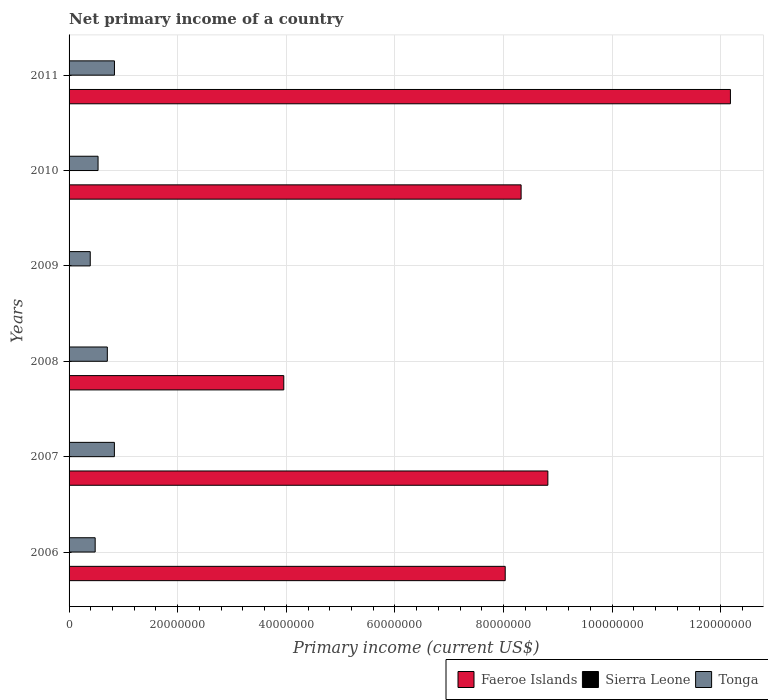Are the number of bars per tick equal to the number of legend labels?
Offer a terse response. No. Are the number of bars on each tick of the Y-axis equal?
Ensure brevity in your answer.  No. How many bars are there on the 3rd tick from the top?
Make the answer very short. 1. How many bars are there on the 6th tick from the bottom?
Your response must be concise. 2. What is the label of the 2nd group of bars from the top?
Make the answer very short. 2010. What is the primary income in Sierra Leone in 2007?
Offer a terse response. 0. Across all years, what is the maximum primary income in Tonga?
Your answer should be very brief. 8.36e+06. What is the total primary income in Sierra Leone in the graph?
Give a very brief answer. 0. What is the difference between the primary income in Faeroe Islands in 2008 and that in 2010?
Provide a short and direct response. -4.37e+07. What is the difference between the primary income in Sierra Leone in 2010 and the primary income in Faeroe Islands in 2007?
Make the answer very short. -8.82e+07. What is the average primary income in Faeroe Islands per year?
Your response must be concise. 6.88e+07. In the year 2010, what is the difference between the primary income in Tonga and primary income in Faeroe Islands?
Give a very brief answer. -7.79e+07. What is the ratio of the primary income in Faeroe Islands in 2008 to that in 2010?
Give a very brief answer. 0.47. Is the primary income in Faeroe Islands in 2010 less than that in 2011?
Ensure brevity in your answer.  Yes. Is the difference between the primary income in Tonga in 2006 and 2008 greater than the difference between the primary income in Faeroe Islands in 2006 and 2008?
Provide a succinct answer. No. What is the difference between the highest and the second highest primary income in Tonga?
Provide a short and direct response. 1.11e+04. What is the difference between the highest and the lowest primary income in Faeroe Islands?
Your answer should be very brief. 1.22e+08. Is the sum of the primary income in Tonga in 2006 and 2008 greater than the maximum primary income in Sierra Leone across all years?
Your answer should be compact. Yes. How many bars are there?
Provide a short and direct response. 11. Are all the bars in the graph horizontal?
Keep it short and to the point. Yes. Does the graph contain any zero values?
Your response must be concise. Yes. Does the graph contain grids?
Keep it short and to the point. Yes. How many legend labels are there?
Your answer should be very brief. 3. What is the title of the graph?
Your answer should be very brief. Net primary income of a country. Does "Europe(developing only)" appear as one of the legend labels in the graph?
Your response must be concise. No. What is the label or title of the X-axis?
Give a very brief answer. Primary income (current US$). What is the Primary income (current US$) in Faeroe Islands in 2006?
Ensure brevity in your answer.  8.03e+07. What is the Primary income (current US$) in Sierra Leone in 2006?
Your answer should be very brief. 0. What is the Primary income (current US$) of Tonga in 2006?
Ensure brevity in your answer.  4.81e+06. What is the Primary income (current US$) in Faeroe Islands in 2007?
Make the answer very short. 8.82e+07. What is the Primary income (current US$) in Tonga in 2007?
Your answer should be compact. 8.35e+06. What is the Primary income (current US$) in Faeroe Islands in 2008?
Your response must be concise. 3.95e+07. What is the Primary income (current US$) of Sierra Leone in 2008?
Ensure brevity in your answer.  0. What is the Primary income (current US$) of Tonga in 2008?
Keep it short and to the point. 7.04e+06. What is the Primary income (current US$) of Tonga in 2009?
Keep it short and to the point. 3.90e+06. What is the Primary income (current US$) in Faeroe Islands in 2010?
Keep it short and to the point. 8.32e+07. What is the Primary income (current US$) of Sierra Leone in 2010?
Make the answer very short. 0. What is the Primary income (current US$) of Tonga in 2010?
Your answer should be compact. 5.34e+06. What is the Primary income (current US$) in Faeroe Islands in 2011?
Offer a terse response. 1.22e+08. What is the Primary income (current US$) in Tonga in 2011?
Keep it short and to the point. 8.36e+06. Across all years, what is the maximum Primary income (current US$) of Faeroe Islands?
Offer a very short reply. 1.22e+08. Across all years, what is the maximum Primary income (current US$) of Tonga?
Offer a very short reply. 8.36e+06. Across all years, what is the minimum Primary income (current US$) of Faeroe Islands?
Ensure brevity in your answer.  0. Across all years, what is the minimum Primary income (current US$) of Tonga?
Provide a short and direct response. 3.90e+06. What is the total Primary income (current US$) in Faeroe Islands in the graph?
Make the answer very short. 4.13e+08. What is the total Primary income (current US$) in Sierra Leone in the graph?
Make the answer very short. 0. What is the total Primary income (current US$) in Tonga in the graph?
Keep it short and to the point. 3.78e+07. What is the difference between the Primary income (current US$) in Faeroe Islands in 2006 and that in 2007?
Give a very brief answer. -7.85e+06. What is the difference between the Primary income (current US$) in Tonga in 2006 and that in 2007?
Offer a very short reply. -3.54e+06. What is the difference between the Primary income (current US$) of Faeroe Islands in 2006 and that in 2008?
Offer a terse response. 4.08e+07. What is the difference between the Primary income (current US$) in Tonga in 2006 and that in 2008?
Provide a succinct answer. -2.24e+06. What is the difference between the Primary income (current US$) of Tonga in 2006 and that in 2009?
Your answer should be compact. 9.08e+05. What is the difference between the Primary income (current US$) of Faeroe Islands in 2006 and that in 2010?
Make the answer very short. -2.93e+06. What is the difference between the Primary income (current US$) in Tonga in 2006 and that in 2010?
Keep it short and to the point. -5.31e+05. What is the difference between the Primary income (current US$) in Faeroe Islands in 2006 and that in 2011?
Make the answer very short. -4.15e+07. What is the difference between the Primary income (current US$) in Tonga in 2006 and that in 2011?
Your answer should be very brief. -3.55e+06. What is the difference between the Primary income (current US$) of Faeroe Islands in 2007 and that in 2008?
Offer a terse response. 4.86e+07. What is the difference between the Primary income (current US$) in Tonga in 2007 and that in 2008?
Provide a short and direct response. 1.30e+06. What is the difference between the Primary income (current US$) of Tonga in 2007 and that in 2009?
Make the answer very short. 4.45e+06. What is the difference between the Primary income (current US$) of Faeroe Islands in 2007 and that in 2010?
Provide a short and direct response. 4.93e+06. What is the difference between the Primary income (current US$) in Tonga in 2007 and that in 2010?
Make the answer very short. 3.01e+06. What is the difference between the Primary income (current US$) in Faeroe Islands in 2007 and that in 2011?
Keep it short and to the point. -3.36e+07. What is the difference between the Primary income (current US$) in Tonga in 2007 and that in 2011?
Your response must be concise. -1.11e+04. What is the difference between the Primary income (current US$) in Tonga in 2008 and that in 2009?
Offer a terse response. 3.14e+06. What is the difference between the Primary income (current US$) of Faeroe Islands in 2008 and that in 2010?
Keep it short and to the point. -4.37e+07. What is the difference between the Primary income (current US$) of Tonga in 2008 and that in 2010?
Provide a succinct answer. 1.71e+06. What is the difference between the Primary income (current US$) of Faeroe Islands in 2008 and that in 2011?
Provide a succinct answer. -8.22e+07. What is the difference between the Primary income (current US$) in Tonga in 2008 and that in 2011?
Offer a very short reply. -1.31e+06. What is the difference between the Primary income (current US$) of Tonga in 2009 and that in 2010?
Provide a short and direct response. -1.44e+06. What is the difference between the Primary income (current US$) in Tonga in 2009 and that in 2011?
Make the answer very short. -4.46e+06. What is the difference between the Primary income (current US$) of Faeroe Islands in 2010 and that in 2011?
Make the answer very short. -3.85e+07. What is the difference between the Primary income (current US$) in Tonga in 2010 and that in 2011?
Make the answer very short. -3.02e+06. What is the difference between the Primary income (current US$) of Faeroe Islands in 2006 and the Primary income (current US$) of Tonga in 2007?
Keep it short and to the point. 7.20e+07. What is the difference between the Primary income (current US$) in Faeroe Islands in 2006 and the Primary income (current US$) in Tonga in 2008?
Make the answer very short. 7.33e+07. What is the difference between the Primary income (current US$) in Faeroe Islands in 2006 and the Primary income (current US$) in Tonga in 2009?
Your answer should be very brief. 7.64e+07. What is the difference between the Primary income (current US$) in Faeroe Islands in 2006 and the Primary income (current US$) in Tonga in 2010?
Give a very brief answer. 7.50e+07. What is the difference between the Primary income (current US$) of Faeroe Islands in 2006 and the Primary income (current US$) of Tonga in 2011?
Your answer should be very brief. 7.20e+07. What is the difference between the Primary income (current US$) in Faeroe Islands in 2007 and the Primary income (current US$) in Tonga in 2008?
Your answer should be very brief. 8.11e+07. What is the difference between the Primary income (current US$) in Faeroe Islands in 2007 and the Primary income (current US$) in Tonga in 2009?
Ensure brevity in your answer.  8.43e+07. What is the difference between the Primary income (current US$) in Faeroe Islands in 2007 and the Primary income (current US$) in Tonga in 2010?
Ensure brevity in your answer.  8.28e+07. What is the difference between the Primary income (current US$) in Faeroe Islands in 2007 and the Primary income (current US$) in Tonga in 2011?
Your response must be concise. 7.98e+07. What is the difference between the Primary income (current US$) in Faeroe Islands in 2008 and the Primary income (current US$) in Tonga in 2009?
Provide a short and direct response. 3.56e+07. What is the difference between the Primary income (current US$) of Faeroe Islands in 2008 and the Primary income (current US$) of Tonga in 2010?
Your answer should be compact. 3.42e+07. What is the difference between the Primary income (current US$) in Faeroe Islands in 2008 and the Primary income (current US$) in Tonga in 2011?
Give a very brief answer. 3.12e+07. What is the difference between the Primary income (current US$) in Faeroe Islands in 2010 and the Primary income (current US$) in Tonga in 2011?
Your answer should be compact. 7.49e+07. What is the average Primary income (current US$) in Faeroe Islands per year?
Offer a terse response. 6.88e+07. What is the average Primary income (current US$) in Tonga per year?
Your answer should be compact. 6.30e+06. In the year 2006, what is the difference between the Primary income (current US$) of Faeroe Islands and Primary income (current US$) of Tonga?
Offer a very short reply. 7.55e+07. In the year 2007, what is the difference between the Primary income (current US$) in Faeroe Islands and Primary income (current US$) in Tonga?
Ensure brevity in your answer.  7.98e+07. In the year 2008, what is the difference between the Primary income (current US$) in Faeroe Islands and Primary income (current US$) in Tonga?
Provide a short and direct response. 3.25e+07. In the year 2010, what is the difference between the Primary income (current US$) of Faeroe Islands and Primary income (current US$) of Tonga?
Offer a very short reply. 7.79e+07. In the year 2011, what is the difference between the Primary income (current US$) of Faeroe Islands and Primary income (current US$) of Tonga?
Offer a terse response. 1.13e+08. What is the ratio of the Primary income (current US$) of Faeroe Islands in 2006 to that in 2007?
Your answer should be compact. 0.91. What is the ratio of the Primary income (current US$) in Tonga in 2006 to that in 2007?
Make the answer very short. 0.58. What is the ratio of the Primary income (current US$) in Faeroe Islands in 2006 to that in 2008?
Offer a very short reply. 2.03. What is the ratio of the Primary income (current US$) in Tonga in 2006 to that in 2008?
Your response must be concise. 0.68. What is the ratio of the Primary income (current US$) of Tonga in 2006 to that in 2009?
Your response must be concise. 1.23. What is the ratio of the Primary income (current US$) of Faeroe Islands in 2006 to that in 2010?
Your answer should be compact. 0.96. What is the ratio of the Primary income (current US$) in Tonga in 2006 to that in 2010?
Make the answer very short. 0.9. What is the ratio of the Primary income (current US$) in Faeroe Islands in 2006 to that in 2011?
Your answer should be compact. 0.66. What is the ratio of the Primary income (current US$) in Tonga in 2006 to that in 2011?
Your answer should be compact. 0.58. What is the ratio of the Primary income (current US$) in Faeroe Islands in 2007 to that in 2008?
Provide a short and direct response. 2.23. What is the ratio of the Primary income (current US$) of Tonga in 2007 to that in 2008?
Offer a very short reply. 1.18. What is the ratio of the Primary income (current US$) of Tonga in 2007 to that in 2009?
Your answer should be very brief. 2.14. What is the ratio of the Primary income (current US$) of Faeroe Islands in 2007 to that in 2010?
Your answer should be very brief. 1.06. What is the ratio of the Primary income (current US$) of Tonga in 2007 to that in 2010?
Offer a very short reply. 1.56. What is the ratio of the Primary income (current US$) of Faeroe Islands in 2007 to that in 2011?
Give a very brief answer. 0.72. What is the ratio of the Primary income (current US$) in Tonga in 2008 to that in 2009?
Provide a short and direct response. 1.81. What is the ratio of the Primary income (current US$) in Faeroe Islands in 2008 to that in 2010?
Give a very brief answer. 0.47. What is the ratio of the Primary income (current US$) of Tonga in 2008 to that in 2010?
Provide a succinct answer. 1.32. What is the ratio of the Primary income (current US$) in Faeroe Islands in 2008 to that in 2011?
Keep it short and to the point. 0.32. What is the ratio of the Primary income (current US$) in Tonga in 2008 to that in 2011?
Keep it short and to the point. 0.84. What is the ratio of the Primary income (current US$) in Tonga in 2009 to that in 2010?
Keep it short and to the point. 0.73. What is the ratio of the Primary income (current US$) in Tonga in 2009 to that in 2011?
Your response must be concise. 0.47. What is the ratio of the Primary income (current US$) of Faeroe Islands in 2010 to that in 2011?
Provide a succinct answer. 0.68. What is the ratio of the Primary income (current US$) in Tonga in 2010 to that in 2011?
Your answer should be very brief. 0.64. What is the difference between the highest and the second highest Primary income (current US$) of Faeroe Islands?
Keep it short and to the point. 3.36e+07. What is the difference between the highest and the second highest Primary income (current US$) of Tonga?
Give a very brief answer. 1.11e+04. What is the difference between the highest and the lowest Primary income (current US$) in Faeroe Islands?
Keep it short and to the point. 1.22e+08. What is the difference between the highest and the lowest Primary income (current US$) in Tonga?
Provide a succinct answer. 4.46e+06. 